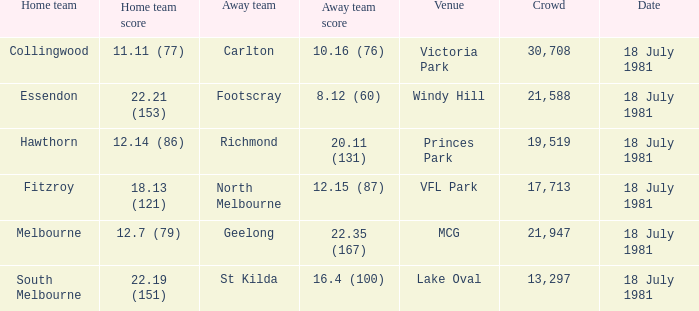What was the away team that played against Fitzroy? North Melbourne. 